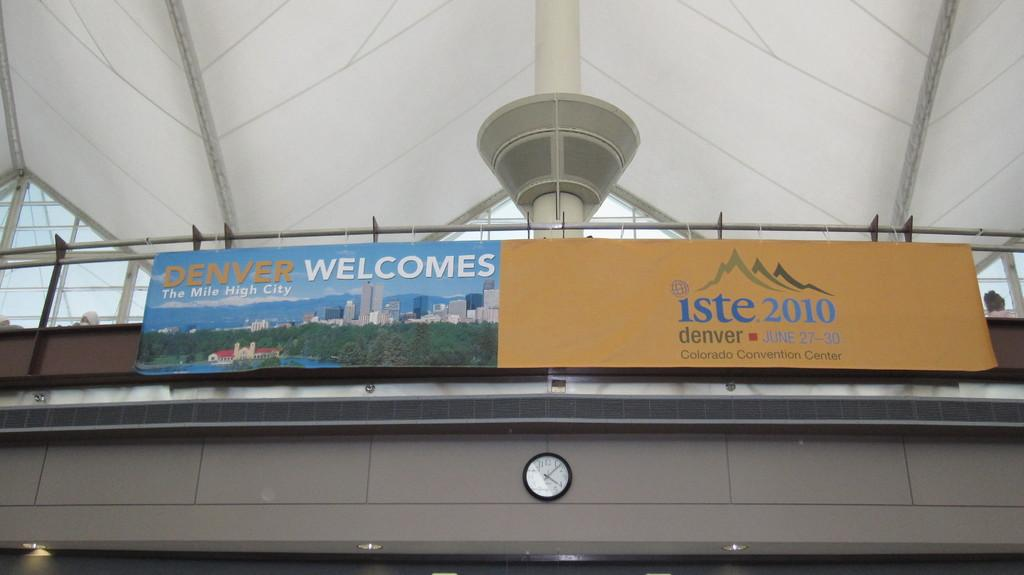<image>
Write a terse but informative summary of the picture. The blue banner is welcoming people to Denver, the mile high city. 